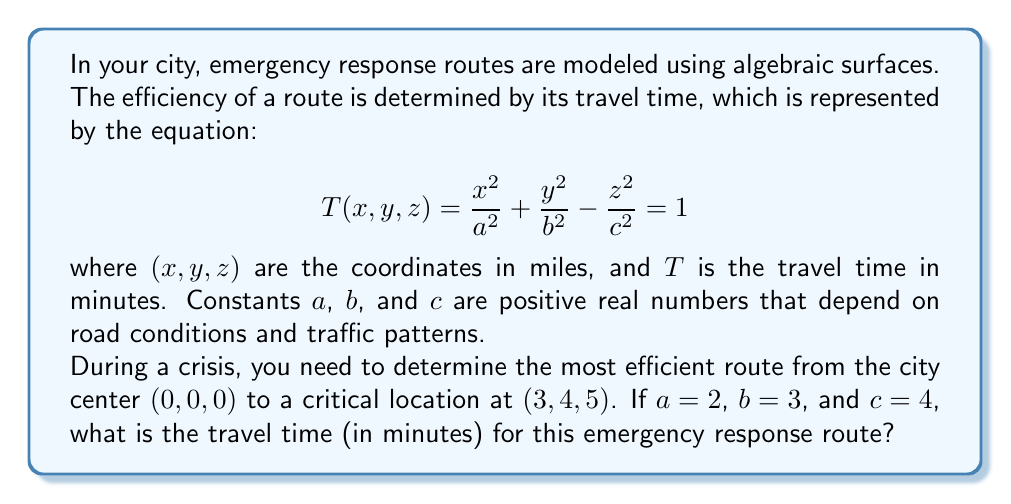Solve this math problem. To solve this problem, we'll follow these steps:

1) We're given the equation for the travel time surface:

   $$T(x,y,z) = \frac{x^2}{a^2} + \frac{y^2}{b^2} - \frac{z^2}{c^2} = 1$$

2) We're also given the values: $a=2$, $b=3$, $c=4$, and the coordinates of the critical location $(3,4,5)$.

3) Let's substitute these values into the equation:

   $$T(3,4,5) = \frac{3^2}{2^2} + \frac{4^2}{3^2} - \frac{5^2}{4^2} = 1$$

4) Now, let's calculate each term:

   $$\frac{3^2}{2^2} = \frac{9}{4} = 2.25$$
   
   $$\frac{4^2}{3^2} = \frac{16}{9} \approx 1.778$$
   
   $$\frac{5^2}{4^2} = \frac{25}{16} = 1.5625$$

5) Substituting these values:

   $$T(3,4,5) = 2.25 + 1.778 - 1.5625 = 2.4655$$

6) This means that the travel time to the critical location is 2.4655 times the unit time represented by the surface equation.

7) Since the original equation is set equal to 1, and this represents the travel time in minutes, we multiply our result by 1 minute to get the final answer.
Answer: 2.4655 minutes 